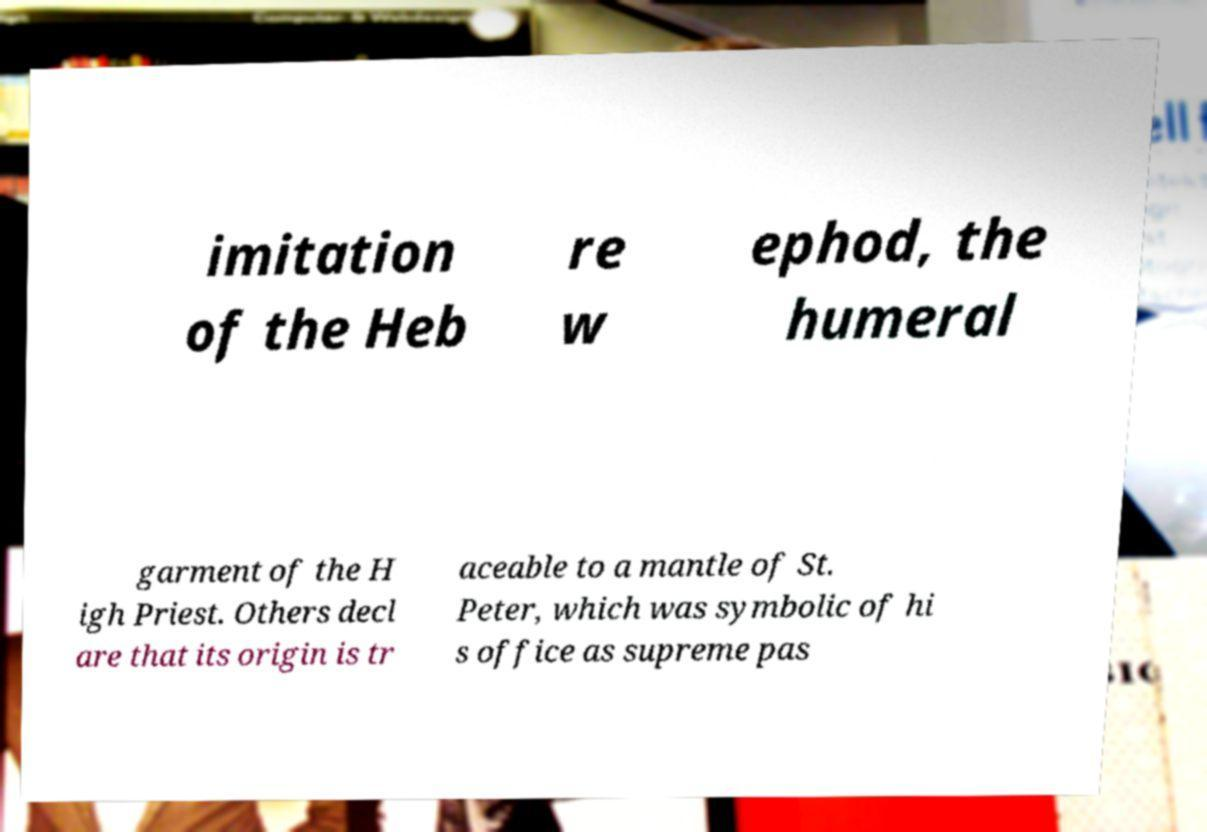Please read and relay the text visible in this image. What does it say? imitation of the Heb re w ephod, the humeral garment of the H igh Priest. Others decl are that its origin is tr aceable to a mantle of St. Peter, which was symbolic of hi s office as supreme pas 